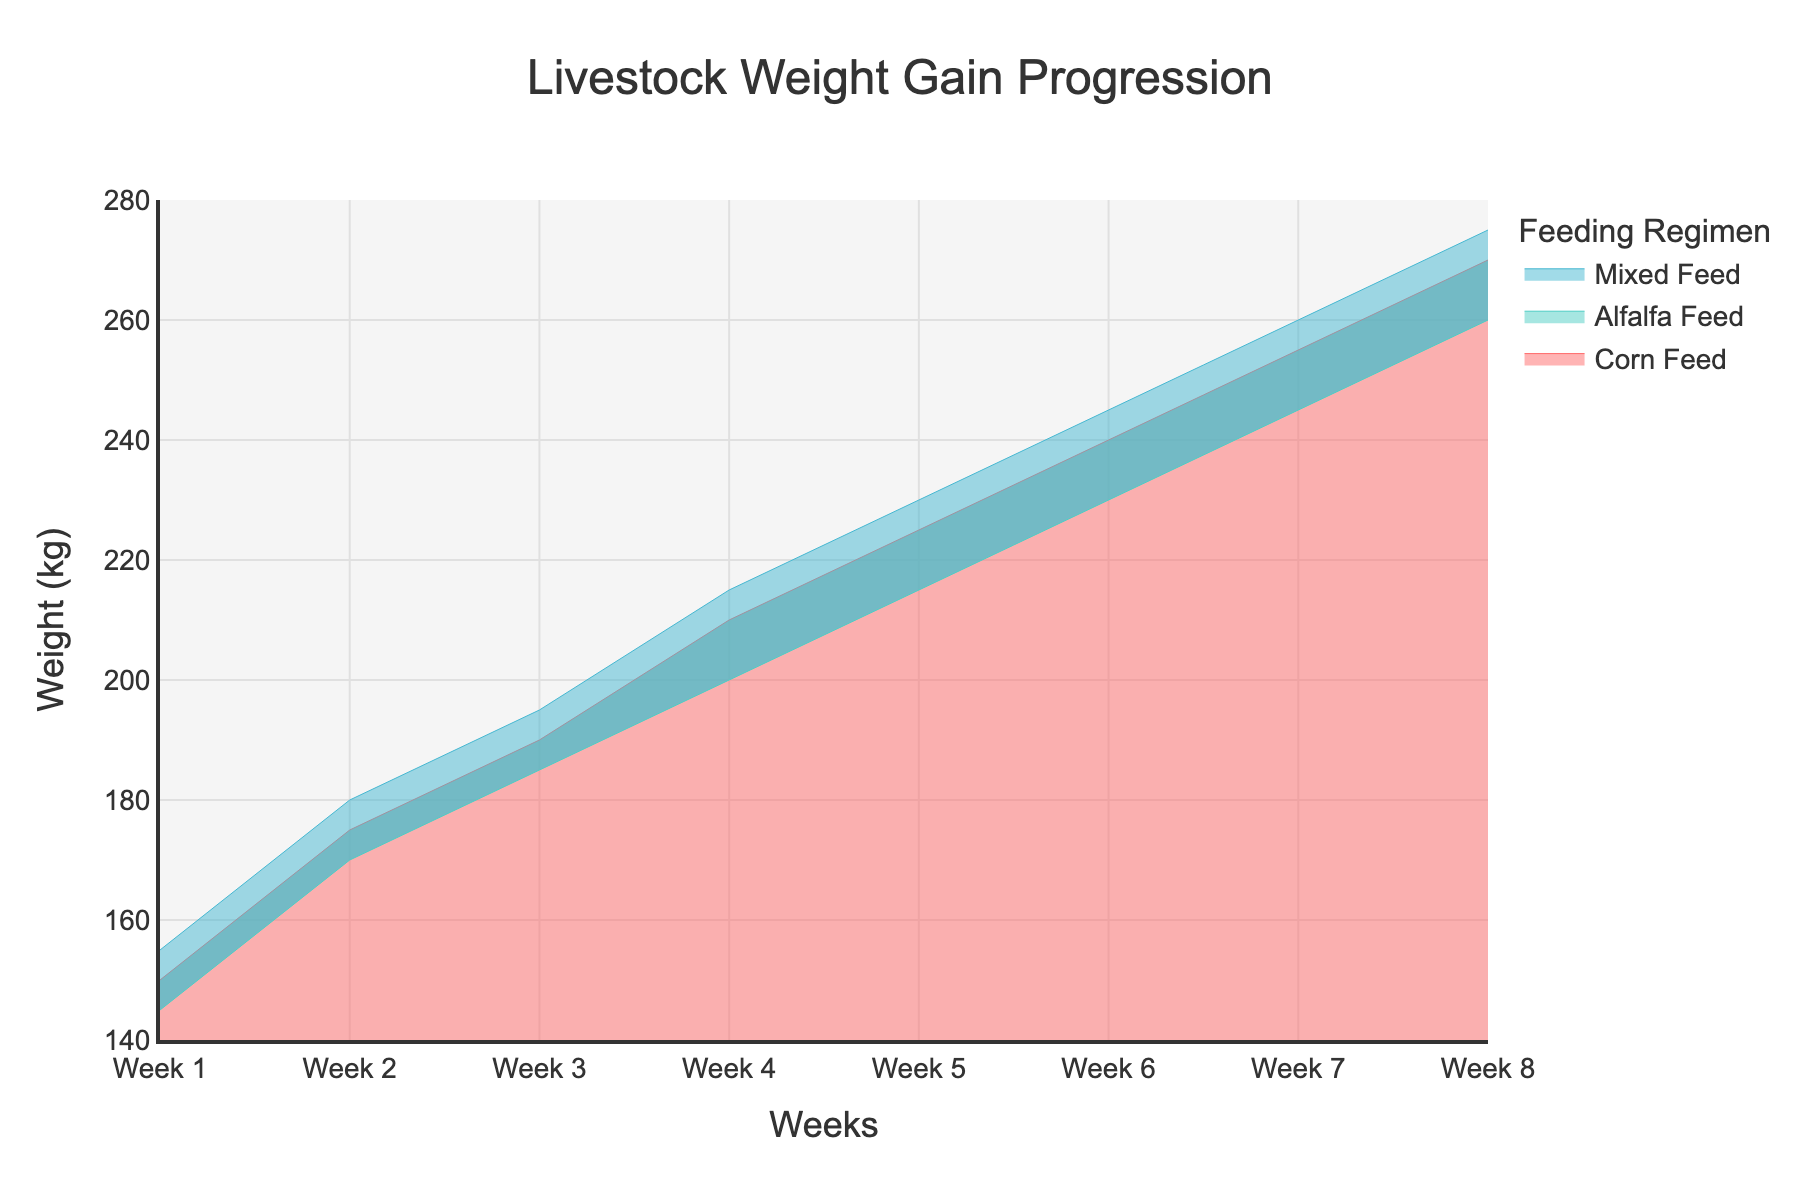What is the title of the chart? The title of the chart is displayed prominently at the top. By reading the text, we can see that the title is "Livestock Weight Gain Progression."
Answer: Livestock Weight Gain Progression How many weeks are represented in the chart? By examining the x-axis, we can see that it starts at "Week 1" and ends at "Week 8". Counting these, we find there are 8 weeks represented.
Answer: 8 Which feeding regimen shows the highest livestock weight gain by Week 8? By looking at the y-values at Week 8 for all feeding regimens, we notice that "Mixed Feed" has the highest value at 275.
Answer: Mixed Feed What is the color used for the "Corn Feed" regimen? "Corn Feed" can be identified by its color in the chart, which is red.
Answer: Red What is the weight difference between "Corn Feed" and "Alfalfa Feed" in Week 4? To find the difference, we look at Week 4: Corn Feed is 210 kg and Alfalfa Feed is 200 kg. The difference is 210 - 200 = 10 kg.
Answer: 10 kg What is the average weight gain for the "Mixed Feed" regimen over the 8 weeks? The weights for Mixed Feed over the weeks are listed. Adding them: 155+180+195+215+230+245+260+275 = 1755. Dividing by 8 weeks, the average weight is 1755/8 = 219.375.
Answer: 219.375 kg In which week does the "Alfalfa Feed" regimen reach 230 kg? By scanning the y-values for "Alfalfa Feed", we see that it hits 230 kg in Week 6.
Answer: Week 6 Which feeding regimen shows the least consistent weight gain progression? Consistency can be observed by the smoothness of the line. Both Corn Feed and Mixed Feed show a smoother progression compared to Alfalfa Feed, which has slightly more varied intervals.
Answer: Alfalfa Feed How much weight did the livestock gain on average per week with the "Corn Feed" regimen? For Corn Feed, we calculate the total gain as 270-150=120 kg over 8 weeks. The average weekly gain is 120/8 = 15 kg.
Answer: 15 kg Which two feeding regimens have the closest weight values in Week 5? In Week 5, Corn Feed is 225 kg, Alfalfa Feed is 215 kg, and Mixed Feed is 230 kg. Comparing them, Alfalfa Feed and Corn Feed have the closest values with a difference of 10 kg.
Answer: Corn Feed and Alfalfa Feed 